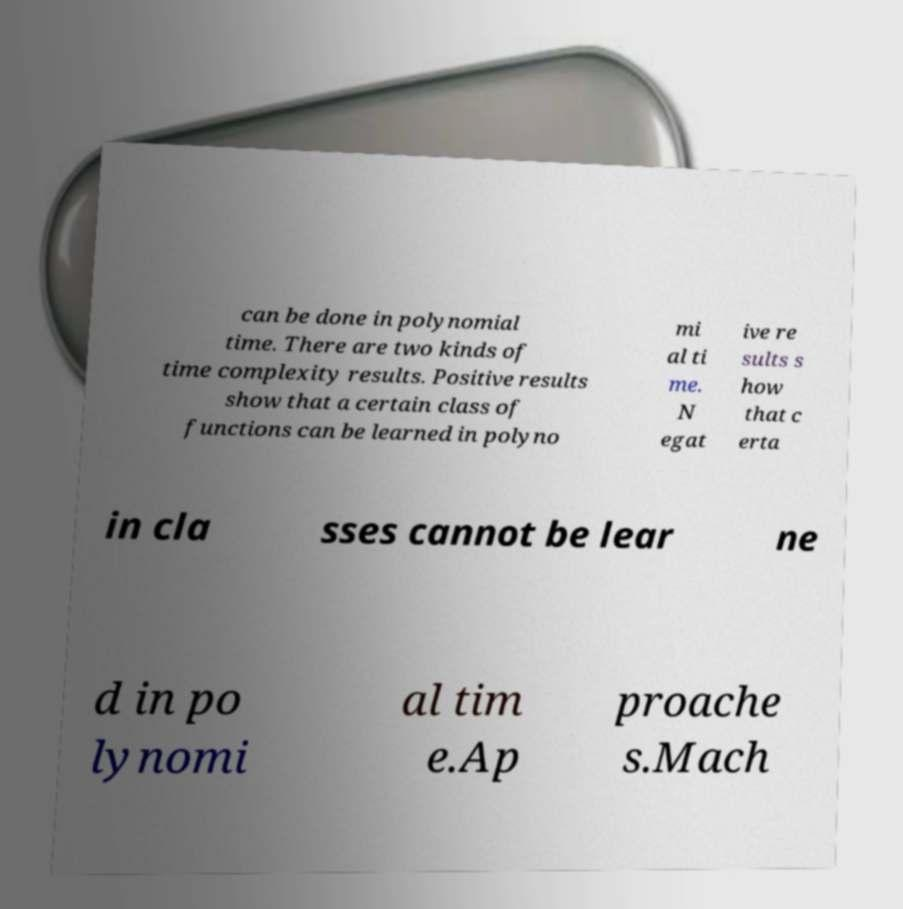Can you accurately transcribe the text from the provided image for me? can be done in polynomial time. There are two kinds of time complexity results. Positive results show that a certain class of functions can be learned in polyno mi al ti me. N egat ive re sults s how that c erta in cla sses cannot be lear ne d in po lynomi al tim e.Ap proache s.Mach 